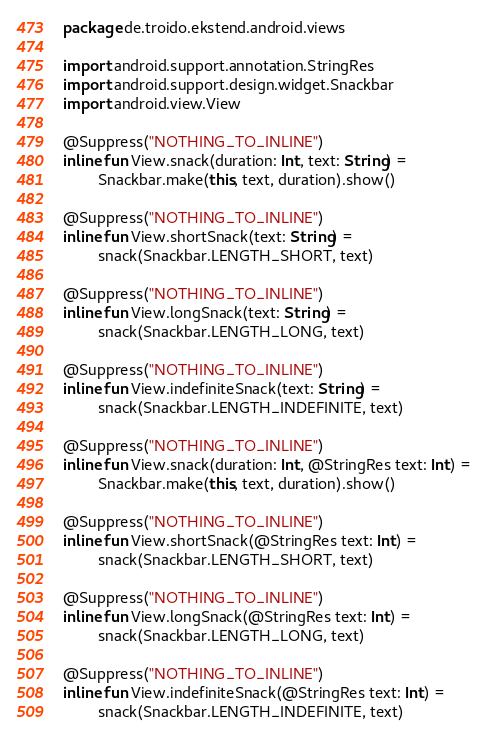Convert code to text. <code><loc_0><loc_0><loc_500><loc_500><_Kotlin_>package de.troido.ekstend.android.views

import android.support.annotation.StringRes
import android.support.design.widget.Snackbar
import android.view.View

@Suppress("NOTHING_TO_INLINE")
inline fun View.snack(duration: Int, text: String) =
        Snackbar.make(this, text, duration).show()

@Suppress("NOTHING_TO_INLINE")
inline fun View.shortSnack(text: String) =
        snack(Snackbar.LENGTH_SHORT, text)

@Suppress("NOTHING_TO_INLINE")
inline fun View.longSnack(text: String) =
        snack(Snackbar.LENGTH_LONG, text)

@Suppress("NOTHING_TO_INLINE")
inline fun View.indefiniteSnack(text: String) =
        snack(Snackbar.LENGTH_INDEFINITE, text)

@Suppress("NOTHING_TO_INLINE")
inline fun View.snack(duration: Int, @StringRes text: Int) =
        Snackbar.make(this, text, duration).show()

@Suppress("NOTHING_TO_INLINE")
inline fun View.shortSnack(@StringRes text: Int) =
        snack(Snackbar.LENGTH_SHORT, text)

@Suppress("NOTHING_TO_INLINE")
inline fun View.longSnack(@StringRes text: Int) =
        snack(Snackbar.LENGTH_LONG, text)

@Suppress("NOTHING_TO_INLINE")
inline fun View.indefiniteSnack(@StringRes text: Int) =
        snack(Snackbar.LENGTH_INDEFINITE, text)
</code> 